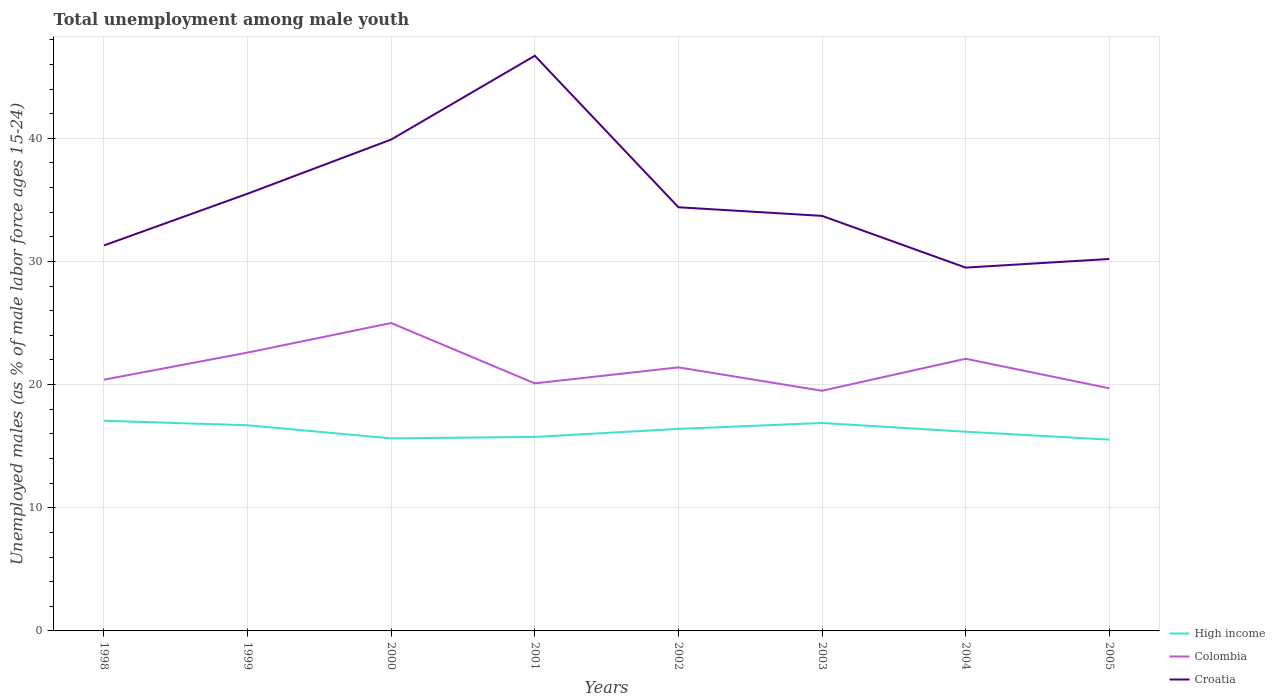How many different coloured lines are there?
Ensure brevity in your answer.  3. Does the line corresponding to Colombia intersect with the line corresponding to Croatia?
Keep it short and to the point. No. Is the number of lines equal to the number of legend labels?
Your answer should be very brief. Yes. Across all years, what is the maximum percentage of unemployed males in in Colombia?
Make the answer very short. 19.5. In which year was the percentage of unemployed males in in Croatia maximum?
Offer a very short reply. 2004. What is the total percentage of unemployed males in in Colombia in the graph?
Ensure brevity in your answer.  -1.3. What is the difference between the highest and the second highest percentage of unemployed males in in Croatia?
Your answer should be very brief. 17.2. How many lines are there?
Offer a terse response. 3. How many years are there in the graph?
Ensure brevity in your answer.  8. What is the title of the graph?
Your response must be concise. Total unemployment among male youth. Does "Timor-Leste" appear as one of the legend labels in the graph?
Provide a short and direct response. No. What is the label or title of the X-axis?
Your answer should be compact. Years. What is the label or title of the Y-axis?
Keep it short and to the point. Unemployed males (as % of male labor force ages 15-24). What is the Unemployed males (as % of male labor force ages 15-24) of High income in 1998?
Your answer should be very brief. 17.06. What is the Unemployed males (as % of male labor force ages 15-24) of Colombia in 1998?
Your response must be concise. 20.4. What is the Unemployed males (as % of male labor force ages 15-24) in Croatia in 1998?
Your answer should be very brief. 31.3. What is the Unemployed males (as % of male labor force ages 15-24) of High income in 1999?
Offer a very short reply. 16.7. What is the Unemployed males (as % of male labor force ages 15-24) of Colombia in 1999?
Give a very brief answer. 22.6. What is the Unemployed males (as % of male labor force ages 15-24) in Croatia in 1999?
Offer a very short reply. 35.5. What is the Unemployed males (as % of male labor force ages 15-24) of High income in 2000?
Your response must be concise. 15.63. What is the Unemployed males (as % of male labor force ages 15-24) of Croatia in 2000?
Make the answer very short. 39.9. What is the Unemployed males (as % of male labor force ages 15-24) of High income in 2001?
Ensure brevity in your answer.  15.75. What is the Unemployed males (as % of male labor force ages 15-24) in Colombia in 2001?
Your answer should be very brief. 20.1. What is the Unemployed males (as % of male labor force ages 15-24) in Croatia in 2001?
Provide a short and direct response. 46.7. What is the Unemployed males (as % of male labor force ages 15-24) in High income in 2002?
Keep it short and to the point. 16.4. What is the Unemployed males (as % of male labor force ages 15-24) of Colombia in 2002?
Your answer should be very brief. 21.4. What is the Unemployed males (as % of male labor force ages 15-24) of Croatia in 2002?
Provide a succinct answer. 34.4. What is the Unemployed males (as % of male labor force ages 15-24) of High income in 2003?
Keep it short and to the point. 16.88. What is the Unemployed males (as % of male labor force ages 15-24) of Croatia in 2003?
Provide a succinct answer. 33.7. What is the Unemployed males (as % of male labor force ages 15-24) of High income in 2004?
Offer a very short reply. 16.18. What is the Unemployed males (as % of male labor force ages 15-24) of Colombia in 2004?
Your answer should be compact. 22.1. What is the Unemployed males (as % of male labor force ages 15-24) in Croatia in 2004?
Keep it short and to the point. 29.5. What is the Unemployed males (as % of male labor force ages 15-24) of High income in 2005?
Give a very brief answer. 15.53. What is the Unemployed males (as % of male labor force ages 15-24) in Colombia in 2005?
Provide a succinct answer. 19.7. What is the Unemployed males (as % of male labor force ages 15-24) of Croatia in 2005?
Give a very brief answer. 30.2. Across all years, what is the maximum Unemployed males (as % of male labor force ages 15-24) of High income?
Ensure brevity in your answer.  17.06. Across all years, what is the maximum Unemployed males (as % of male labor force ages 15-24) in Croatia?
Make the answer very short. 46.7. Across all years, what is the minimum Unemployed males (as % of male labor force ages 15-24) of High income?
Your answer should be compact. 15.53. Across all years, what is the minimum Unemployed males (as % of male labor force ages 15-24) of Colombia?
Provide a succinct answer. 19.5. Across all years, what is the minimum Unemployed males (as % of male labor force ages 15-24) in Croatia?
Provide a short and direct response. 29.5. What is the total Unemployed males (as % of male labor force ages 15-24) of High income in the graph?
Make the answer very short. 130.14. What is the total Unemployed males (as % of male labor force ages 15-24) of Colombia in the graph?
Give a very brief answer. 170.8. What is the total Unemployed males (as % of male labor force ages 15-24) in Croatia in the graph?
Provide a short and direct response. 281.2. What is the difference between the Unemployed males (as % of male labor force ages 15-24) of High income in 1998 and that in 1999?
Offer a very short reply. 0.37. What is the difference between the Unemployed males (as % of male labor force ages 15-24) in Colombia in 1998 and that in 1999?
Offer a very short reply. -2.2. What is the difference between the Unemployed males (as % of male labor force ages 15-24) of Croatia in 1998 and that in 1999?
Ensure brevity in your answer.  -4.2. What is the difference between the Unemployed males (as % of male labor force ages 15-24) of High income in 1998 and that in 2000?
Offer a terse response. 1.43. What is the difference between the Unemployed males (as % of male labor force ages 15-24) of Colombia in 1998 and that in 2000?
Make the answer very short. -4.6. What is the difference between the Unemployed males (as % of male labor force ages 15-24) of Croatia in 1998 and that in 2000?
Provide a short and direct response. -8.6. What is the difference between the Unemployed males (as % of male labor force ages 15-24) of High income in 1998 and that in 2001?
Offer a terse response. 1.31. What is the difference between the Unemployed males (as % of male labor force ages 15-24) in Colombia in 1998 and that in 2001?
Make the answer very short. 0.3. What is the difference between the Unemployed males (as % of male labor force ages 15-24) in Croatia in 1998 and that in 2001?
Keep it short and to the point. -15.4. What is the difference between the Unemployed males (as % of male labor force ages 15-24) in High income in 1998 and that in 2002?
Offer a terse response. 0.66. What is the difference between the Unemployed males (as % of male labor force ages 15-24) of High income in 1998 and that in 2003?
Your answer should be very brief. 0.18. What is the difference between the Unemployed males (as % of male labor force ages 15-24) of Colombia in 1998 and that in 2003?
Your answer should be very brief. 0.9. What is the difference between the Unemployed males (as % of male labor force ages 15-24) in High income in 1998 and that in 2004?
Offer a terse response. 0.89. What is the difference between the Unemployed males (as % of male labor force ages 15-24) in Croatia in 1998 and that in 2004?
Provide a short and direct response. 1.8. What is the difference between the Unemployed males (as % of male labor force ages 15-24) in High income in 1998 and that in 2005?
Keep it short and to the point. 1.53. What is the difference between the Unemployed males (as % of male labor force ages 15-24) in Colombia in 1998 and that in 2005?
Provide a succinct answer. 0.7. What is the difference between the Unemployed males (as % of male labor force ages 15-24) in Croatia in 1998 and that in 2005?
Your answer should be very brief. 1.1. What is the difference between the Unemployed males (as % of male labor force ages 15-24) of High income in 1999 and that in 2000?
Provide a succinct answer. 1.06. What is the difference between the Unemployed males (as % of male labor force ages 15-24) in Croatia in 1999 and that in 2000?
Your answer should be compact. -4.4. What is the difference between the Unemployed males (as % of male labor force ages 15-24) in High income in 1999 and that in 2001?
Offer a terse response. 0.94. What is the difference between the Unemployed males (as % of male labor force ages 15-24) in High income in 1999 and that in 2002?
Keep it short and to the point. 0.29. What is the difference between the Unemployed males (as % of male labor force ages 15-24) in High income in 1999 and that in 2003?
Your answer should be compact. -0.19. What is the difference between the Unemployed males (as % of male labor force ages 15-24) in High income in 1999 and that in 2004?
Make the answer very short. 0.52. What is the difference between the Unemployed males (as % of male labor force ages 15-24) of Colombia in 1999 and that in 2004?
Give a very brief answer. 0.5. What is the difference between the Unemployed males (as % of male labor force ages 15-24) of High income in 1999 and that in 2005?
Make the answer very short. 1.17. What is the difference between the Unemployed males (as % of male labor force ages 15-24) in Colombia in 1999 and that in 2005?
Keep it short and to the point. 2.9. What is the difference between the Unemployed males (as % of male labor force ages 15-24) of Croatia in 1999 and that in 2005?
Your answer should be very brief. 5.3. What is the difference between the Unemployed males (as % of male labor force ages 15-24) in High income in 2000 and that in 2001?
Give a very brief answer. -0.12. What is the difference between the Unemployed males (as % of male labor force ages 15-24) in Croatia in 2000 and that in 2001?
Your response must be concise. -6.8. What is the difference between the Unemployed males (as % of male labor force ages 15-24) in High income in 2000 and that in 2002?
Make the answer very short. -0.77. What is the difference between the Unemployed males (as % of male labor force ages 15-24) of Colombia in 2000 and that in 2002?
Your answer should be compact. 3.6. What is the difference between the Unemployed males (as % of male labor force ages 15-24) of High income in 2000 and that in 2003?
Offer a very short reply. -1.25. What is the difference between the Unemployed males (as % of male labor force ages 15-24) in Croatia in 2000 and that in 2003?
Provide a short and direct response. 6.2. What is the difference between the Unemployed males (as % of male labor force ages 15-24) in High income in 2000 and that in 2004?
Provide a succinct answer. -0.54. What is the difference between the Unemployed males (as % of male labor force ages 15-24) of Colombia in 2000 and that in 2004?
Keep it short and to the point. 2.9. What is the difference between the Unemployed males (as % of male labor force ages 15-24) in Croatia in 2000 and that in 2004?
Offer a terse response. 10.4. What is the difference between the Unemployed males (as % of male labor force ages 15-24) in High income in 2000 and that in 2005?
Offer a terse response. 0.1. What is the difference between the Unemployed males (as % of male labor force ages 15-24) in Colombia in 2000 and that in 2005?
Keep it short and to the point. 5.3. What is the difference between the Unemployed males (as % of male labor force ages 15-24) of Croatia in 2000 and that in 2005?
Offer a very short reply. 9.7. What is the difference between the Unemployed males (as % of male labor force ages 15-24) of High income in 2001 and that in 2002?
Provide a succinct answer. -0.65. What is the difference between the Unemployed males (as % of male labor force ages 15-24) of High income in 2001 and that in 2003?
Keep it short and to the point. -1.13. What is the difference between the Unemployed males (as % of male labor force ages 15-24) in Croatia in 2001 and that in 2003?
Ensure brevity in your answer.  13. What is the difference between the Unemployed males (as % of male labor force ages 15-24) in High income in 2001 and that in 2004?
Give a very brief answer. -0.42. What is the difference between the Unemployed males (as % of male labor force ages 15-24) of Colombia in 2001 and that in 2004?
Keep it short and to the point. -2. What is the difference between the Unemployed males (as % of male labor force ages 15-24) of High income in 2001 and that in 2005?
Give a very brief answer. 0.22. What is the difference between the Unemployed males (as % of male labor force ages 15-24) in Croatia in 2001 and that in 2005?
Ensure brevity in your answer.  16.5. What is the difference between the Unemployed males (as % of male labor force ages 15-24) of High income in 2002 and that in 2003?
Give a very brief answer. -0.48. What is the difference between the Unemployed males (as % of male labor force ages 15-24) in Colombia in 2002 and that in 2003?
Your response must be concise. 1.9. What is the difference between the Unemployed males (as % of male labor force ages 15-24) of Croatia in 2002 and that in 2003?
Make the answer very short. 0.7. What is the difference between the Unemployed males (as % of male labor force ages 15-24) of High income in 2002 and that in 2004?
Your response must be concise. 0.23. What is the difference between the Unemployed males (as % of male labor force ages 15-24) in Croatia in 2002 and that in 2004?
Offer a terse response. 4.9. What is the difference between the Unemployed males (as % of male labor force ages 15-24) in High income in 2002 and that in 2005?
Your answer should be very brief. 0.87. What is the difference between the Unemployed males (as % of male labor force ages 15-24) in Colombia in 2002 and that in 2005?
Ensure brevity in your answer.  1.7. What is the difference between the Unemployed males (as % of male labor force ages 15-24) of High income in 2003 and that in 2004?
Offer a terse response. 0.71. What is the difference between the Unemployed males (as % of male labor force ages 15-24) in Colombia in 2003 and that in 2004?
Keep it short and to the point. -2.6. What is the difference between the Unemployed males (as % of male labor force ages 15-24) of High income in 2003 and that in 2005?
Your answer should be very brief. 1.35. What is the difference between the Unemployed males (as % of male labor force ages 15-24) of Colombia in 2003 and that in 2005?
Your response must be concise. -0.2. What is the difference between the Unemployed males (as % of male labor force ages 15-24) in Croatia in 2003 and that in 2005?
Offer a very short reply. 3.5. What is the difference between the Unemployed males (as % of male labor force ages 15-24) in High income in 2004 and that in 2005?
Your answer should be very brief. 0.64. What is the difference between the Unemployed males (as % of male labor force ages 15-24) of Colombia in 2004 and that in 2005?
Ensure brevity in your answer.  2.4. What is the difference between the Unemployed males (as % of male labor force ages 15-24) in Croatia in 2004 and that in 2005?
Ensure brevity in your answer.  -0.7. What is the difference between the Unemployed males (as % of male labor force ages 15-24) of High income in 1998 and the Unemployed males (as % of male labor force ages 15-24) of Colombia in 1999?
Make the answer very short. -5.54. What is the difference between the Unemployed males (as % of male labor force ages 15-24) of High income in 1998 and the Unemployed males (as % of male labor force ages 15-24) of Croatia in 1999?
Your answer should be compact. -18.43. What is the difference between the Unemployed males (as % of male labor force ages 15-24) of Colombia in 1998 and the Unemployed males (as % of male labor force ages 15-24) of Croatia in 1999?
Give a very brief answer. -15.1. What is the difference between the Unemployed males (as % of male labor force ages 15-24) in High income in 1998 and the Unemployed males (as % of male labor force ages 15-24) in Colombia in 2000?
Your answer should be compact. -7.93. What is the difference between the Unemployed males (as % of male labor force ages 15-24) of High income in 1998 and the Unemployed males (as % of male labor force ages 15-24) of Croatia in 2000?
Provide a succinct answer. -22.84. What is the difference between the Unemployed males (as % of male labor force ages 15-24) of Colombia in 1998 and the Unemployed males (as % of male labor force ages 15-24) of Croatia in 2000?
Your answer should be compact. -19.5. What is the difference between the Unemployed males (as % of male labor force ages 15-24) in High income in 1998 and the Unemployed males (as % of male labor force ages 15-24) in Colombia in 2001?
Provide a short and direct response. -3.04. What is the difference between the Unemployed males (as % of male labor force ages 15-24) of High income in 1998 and the Unemployed males (as % of male labor force ages 15-24) of Croatia in 2001?
Make the answer very short. -29.64. What is the difference between the Unemployed males (as % of male labor force ages 15-24) in Colombia in 1998 and the Unemployed males (as % of male labor force ages 15-24) in Croatia in 2001?
Make the answer very short. -26.3. What is the difference between the Unemployed males (as % of male labor force ages 15-24) of High income in 1998 and the Unemployed males (as % of male labor force ages 15-24) of Colombia in 2002?
Make the answer very short. -4.33. What is the difference between the Unemployed males (as % of male labor force ages 15-24) in High income in 1998 and the Unemployed males (as % of male labor force ages 15-24) in Croatia in 2002?
Offer a terse response. -17.34. What is the difference between the Unemployed males (as % of male labor force ages 15-24) of Colombia in 1998 and the Unemployed males (as % of male labor force ages 15-24) of Croatia in 2002?
Your answer should be very brief. -14. What is the difference between the Unemployed males (as % of male labor force ages 15-24) in High income in 1998 and the Unemployed males (as % of male labor force ages 15-24) in Colombia in 2003?
Your answer should be very brief. -2.44. What is the difference between the Unemployed males (as % of male labor force ages 15-24) in High income in 1998 and the Unemployed males (as % of male labor force ages 15-24) in Croatia in 2003?
Make the answer very short. -16.64. What is the difference between the Unemployed males (as % of male labor force ages 15-24) of Colombia in 1998 and the Unemployed males (as % of male labor force ages 15-24) of Croatia in 2003?
Offer a very short reply. -13.3. What is the difference between the Unemployed males (as % of male labor force ages 15-24) of High income in 1998 and the Unemployed males (as % of male labor force ages 15-24) of Colombia in 2004?
Offer a very short reply. -5.04. What is the difference between the Unemployed males (as % of male labor force ages 15-24) in High income in 1998 and the Unemployed males (as % of male labor force ages 15-24) in Croatia in 2004?
Give a very brief answer. -12.44. What is the difference between the Unemployed males (as % of male labor force ages 15-24) of High income in 1998 and the Unemployed males (as % of male labor force ages 15-24) of Colombia in 2005?
Offer a very short reply. -2.63. What is the difference between the Unemployed males (as % of male labor force ages 15-24) of High income in 1998 and the Unemployed males (as % of male labor force ages 15-24) of Croatia in 2005?
Keep it short and to the point. -13.13. What is the difference between the Unemployed males (as % of male labor force ages 15-24) in High income in 1999 and the Unemployed males (as % of male labor force ages 15-24) in Colombia in 2000?
Offer a very short reply. -8.3. What is the difference between the Unemployed males (as % of male labor force ages 15-24) of High income in 1999 and the Unemployed males (as % of male labor force ages 15-24) of Croatia in 2000?
Keep it short and to the point. -23.2. What is the difference between the Unemployed males (as % of male labor force ages 15-24) in Colombia in 1999 and the Unemployed males (as % of male labor force ages 15-24) in Croatia in 2000?
Provide a short and direct response. -17.3. What is the difference between the Unemployed males (as % of male labor force ages 15-24) in High income in 1999 and the Unemployed males (as % of male labor force ages 15-24) in Colombia in 2001?
Ensure brevity in your answer.  -3.4. What is the difference between the Unemployed males (as % of male labor force ages 15-24) in High income in 1999 and the Unemployed males (as % of male labor force ages 15-24) in Croatia in 2001?
Offer a terse response. -30. What is the difference between the Unemployed males (as % of male labor force ages 15-24) of Colombia in 1999 and the Unemployed males (as % of male labor force ages 15-24) of Croatia in 2001?
Offer a terse response. -24.1. What is the difference between the Unemployed males (as % of male labor force ages 15-24) of High income in 1999 and the Unemployed males (as % of male labor force ages 15-24) of Colombia in 2002?
Keep it short and to the point. -4.7. What is the difference between the Unemployed males (as % of male labor force ages 15-24) of High income in 1999 and the Unemployed males (as % of male labor force ages 15-24) of Croatia in 2002?
Your answer should be very brief. -17.7. What is the difference between the Unemployed males (as % of male labor force ages 15-24) of Colombia in 1999 and the Unemployed males (as % of male labor force ages 15-24) of Croatia in 2002?
Your answer should be very brief. -11.8. What is the difference between the Unemployed males (as % of male labor force ages 15-24) in High income in 1999 and the Unemployed males (as % of male labor force ages 15-24) in Colombia in 2003?
Offer a very short reply. -2.8. What is the difference between the Unemployed males (as % of male labor force ages 15-24) of High income in 1999 and the Unemployed males (as % of male labor force ages 15-24) of Croatia in 2003?
Your response must be concise. -17. What is the difference between the Unemployed males (as % of male labor force ages 15-24) of Colombia in 1999 and the Unemployed males (as % of male labor force ages 15-24) of Croatia in 2003?
Provide a short and direct response. -11.1. What is the difference between the Unemployed males (as % of male labor force ages 15-24) of High income in 1999 and the Unemployed males (as % of male labor force ages 15-24) of Colombia in 2004?
Your answer should be very brief. -5.4. What is the difference between the Unemployed males (as % of male labor force ages 15-24) in High income in 1999 and the Unemployed males (as % of male labor force ages 15-24) in Croatia in 2004?
Keep it short and to the point. -12.8. What is the difference between the Unemployed males (as % of male labor force ages 15-24) of Colombia in 1999 and the Unemployed males (as % of male labor force ages 15-24) of Croatia in 2004?
Your answer should be very brief. -6.9. What is the difference between the Unemployed males (as % of male labor force ages 15-24) of High income in 1999 and the Unemployed males (as % of male labor force ages 15-24) of Colombia in 2005?
Offer a very short reply. -3. What is the difference between the Unemployed males (as % of male labor force ages 15-24) of High income in 1999 and the Unemployed males (as % of male labor force ages 15-24) of Croatia in 2005?
Provide a succinct answer. -13.5. What is the difference between the Unemployed males (as % of male labor force ages 15-24) of High income in 2000 and the Unemployed males (as % of male labor force ages 15-24) of Colombia in 2001?
Give a very brief answer. -4.47. What is the difference between the Unemployed males (as % of male labor force ages 15-24) in High income in 2000 and the Unemployed males (as % of male labor force ages 15-24) in Croatia in 2001?
Ensure brevity in your answer.  -31.07. What is the difference between the Unemployed males (as % of male labor force ages 15-24) in Colombia in 2000 and the Unemployed males (as % of male labor force ages 15-24) in Croatia in 2001?
Your response must be concise. -21.7. What is the difference between the Unemployed males (as % of male labor force ages 15-24) of High income in 2000 and the Unemployed males (as % of male labor force ages 15-24) of Colombia in 2002?
Keep it short and to the point. -5.77. What is the difference between the Unemployed males (as % of male labor force ages 15-24) of High income in 2000 and the Unemployed males (as % of male labor force ages 15-24) of Croatia in 2002?
Your response must be concise. -18.77. What is the difference between the Unemployed males (as % of male labor force ages 15-24) of High income in 2000 and the Unemployed males (as % of male labor force ages 15-24) of Colombia in 2003?
Ensure brevity in your answer.  -3.87. What is the difference between the Unemployed males (as % of male labor force ages 15-24) of High income in 2000 and the Unemployed males (as % of male labor force ages 15-24) of Croatia in 2003?
Your answer should be very brief. -18.07. What is the difference between the Unemployed males (as % of male labor force ages 15-24) of Colombia in 2000 and the Unemployed males (as % of male labor force ages 15-24) of Croatia in 2003?
Keep it short and to the point. -8.7. What is the difference between the Unemployed males (as % of male labor force ages 15-24) in High income in 2000 and the Unemployed males (as % of male labor force ages 15-24) in Colombia in 2004?
Provide a short and direct response. -6.47. What is the difference between the Unemployed males (as % of male labor force ages 15-24) of High income in 2000 and the Unemployed males (as % of male labor force ages 15-24) of Croatia in 2004?
Give a very brief answer. -13.87. What is the difference between the Unemployed males (as % of male labor force ages 15-24) of Colombia in 2000 and the Unemployed males (as % of male labor force ages 15-24) of Croatia in 2004?
Provide a succinct answer. -4.5. What is the difference between the Unemployed males (as % of male labor force ages 15-24) of High income in 2000 and the Unemployed males (as % of male labor force ages 15-24) of Colombia in 2005?
Provide a succinct answer. -4.07. What is the difference between the Unemployed males (as % of male labor force ages 15-24) of High income in 2000 and the Unemployed males (as % of male labor force ages 15-24) of Croatia in 2005?
Provide a succinct answer. -14.57. What is the difference between the Unemployed males (as % of male labor force ages 15-24) of High income in 2001 and the Unemployed males (as % of male labor force ages 15-24) of Colombia in 2002?
Provide a succinct answer. -5.65. What is the difference between the Unemployed males (as % of male labor force ages 15-24) in High income in 2001 and the Unemployed males (as % of male labor force ages 15-24) in Croatia in 2002?
Offer a terse response. -18.65. What is the difference between the Unemployed males (as % of male labor force ages 15-24) in Colombia in 2001 and the Unemployed males (as % of male labor force ages 15-24) in Croatia in 2002?
Ensure brevity in your answer.  -14.3. What is the difference between the Unemployed males (as % of male labor force ages 15-24) in High income in 2001 and the Unemployed males (as % of male labor force ages 15-24) in Colombia in 2003?
Make the answer very short. -3.75. What is the difference between the Unemployed males (as % of male labor force ages 15-24) of High income in 2001 and the Unemployed males (as % of male labor force ages 15-24) of Croatia in 2003?
Your answer should be compact. -17.95. What is the difference between the Unemployed males (as % of male labor force ages 15-24) in High income in 2001 and the Unemployed males (as % of male labor force ages 15-24) in Colombia in 2004?
Your response must be concise. -6.35. What is the difference between the Unemployed males (as % of male labor force ages 15-24) of High income in 2001 and the Unemployed males (as % of male labor force ages 15-24) of Croatia in 2004?
Your answer should be very brief. -13.75. What is the difference between the Unemployed males (as % of male labor force ages 15-24) in Colombia in 2001 and the Unemployed males (as % of male labor force ages 15-24) in Croatia in 2004?
Provide a short and direct response. -9.4. What is the difference between the Unemployed males (as % of male labor force ages 15-24) in High income in 2001 and the Unemployed males (as % of male labor force ages 15-24) in Colombia in 2005?
Offer a terse response. -3.95. What is the difference between the Unemployed males (as % of male labor force ages 15-24) of High income in 2001 and the Unemployed males (as % of male labor force ages 15-24) of Croatia in 2005?
Your answer should be compact. -14.45. What is the difference between the Unemployed males (as % of male labor force ages 15-24) of High income in 2002 and the Unemployed males (as % of male labor force ages 15-24) of Colombia in 2003?
Keep it short and to the point. -3.1. What is the difference between the Unemployed males (as % of male labor force ages 15-24) in High income in 2002 and the Unemployed males (as % of male labor force ages 15-24) in Croatia in 2003?
Offer a very short reply. -17.3. What is the difference between the Unemployed males (as % of male labor force ages 15-24) in High income in 2002 and the Unemployed males (as % of male labor force ages 15-24) in Colombia in 2004?
Offer a very short reply. -5.7. What is the difference between the Unemployed males (as % of male labor force ages 15-24) of High income in 2002 and the Unemployed males (as % of male labor force ages 15-24) of Croatia in 2004?
Offer a terse response. -13.1. What is the difference between the Unemployed males (as % of male labor force ages 15-24) in High income in 2002 and the Unemployed males (as % of male labor force ages 15-24) in Colombia in 2005?
Ensure brevity in your answer.  -3.3. What is the difference between the Unemployed males (as % of male labor force ages 15-24) of High income in 2002 and the Unemployed males (as % of male labor force ages 15-24) of Croatia in 2005?
Your answer should be very brief. -13.8. What is the difference between the Unemployed males (as % of male labor force ages 15-24) in High income in 2003 and the Unemployed males (as % of male labor force ages 15-24) in Colombia in 2004?
Keep it short and to the point. -5.22. What is the difference between the Unemployed males (as % of male labor force ages 15-24) in High income in 2003 and the Unemployed males (as % of male labor force ages 15-24) in Croatia in 2004?
Make the answer very short. -12.62. What is the difference between the Unemployed males (as % of male labor force ages 15-24) in High income in 2003 and the Unemployed males (as % of male labor force ages 15-24) in Colombia in 2005?
Make the answer very short. -2.82. What is the difference between the Unemployed males (as % of male labor force ages 15-24) of High income in 2003 and the Unemployed males (as % of male labor force ages 15-24) of Croatia in 2005?
Offer a terse response. -13.32. What is the difference between the Unemployed males (as % of male labor force ages 15-24) of High income in 2004 and the Unemployed males (as % of male labor force ages 15-24) of Colombia in 2005?
Your response must be concise. -3.52. What is the difference between the Unemployed males (as % of male labor force ages 15-24) in High income in 2004 and the Unemployed males (as % of male labor force ages 15-24) in Croatia in 2005?
Offer a very short reply. -14.02. What is the difference between the Unemployed males (as % of male labor force ages 15-24) of Colombia in 2004 and the Unemployed males (as % of male labor force ages 15-24) of Croatia in 2005?
Your answer should be very brief. -8.1. What is the average Unemployed males (as % of male labor force ages 15-24) of High income per year?
Ensure brevity in your answer.  16.27. What is the average Unemployed males (as % of male labor force ages 15-24) in Colombia per year?
Provide a succinct answer. 21.35. What is the average Unemployed males (as % of male labor force ages 15-24) of Croatia per year?
Your answer should be very brief. 35.15. In the year 1998, what is the difference between the Unemployed males (as % of male labor force ages 15-24) in High income and Unemployed males (as % of male labor force ages 15-24) in Colombia?
Your answer should be compact. -3.33. In the year 1998, what is the difference between the Unemployed males (as % of male labor force ages 15-24) in High income and Unemployed males (as % of male labor force ages 15-24) in Croatia?
Offer a terse response. -14.23. In the year 1998, what is the difference between the Unemployed males (as % of male labor force ages 15-24) in Colombia and Unemployed males (as % of male labor force ages 15-24) in Croatia?
Your response must be concise. -10.9. In the year 1999, what is the difference between the Unemployed males (as % of male labor force ages 15-24) of High income and Unemployed males (as % of male labor force ages 15-24) of Colombia?
Make the answer very short. -5.9. In the year 1999, what is the difference between the Unemployed males (as % of male labor force ages 15-24) of High income and Unemployed males (as % of male labor force ages 15-24) of Croatia?
Your answer should be compact. -18.8. In the year 1999, what is the difference between the Unemployed males (as % of male labor force ages 15-24) of Colombia and Unemployed males (as % of male labor force ages 15-24) of Croatia?
Make the answer very short. -12.9. In the year 2000, what is the difference between the Unemployed males (as % of male labor force ages 15-24) of High income and Unemployed males (as % of male labor force ages 15-24) of Colombia?
Your response must be concise. -9.37. In the year 2000, what is the difference between the Unemployed males (as % of male labor force ages 15-24) in High income and Unemployed males (as % of male labor force ages 15-24) in Croatia?
Keep it short and to the point. -24.27. In the year 2000, what is the difference between the Unemployed males (as % of male labor force ages 15-24) in Colombia and Unemployed males (as % of male labor force ages 15-24) in Croatia?
Make the answer very short. -14.9. In the year 2001, what is the difference between the Unemployed males (as % of male labor force ages 15-24) of High income and Unemployed males (as % of male labor force ages 15-24) of Colombia?
Keep it short and to the point. -4.35. In the year 2001, what is the difference between the Unemployed males (as % of male labor force ages 15-24) in High income and Unemployed males (as % of male labor force ages 15-24) in Croatia?
Offer a terse response. -30.95. In the year 2001, what is the difference between the Unemployed males (as % of male labor force ages 15-24) in Colombia and Unemployed males (as % of male labor force ages 15-24) in Croatia?
Offer a very short reply. -26.6. In the year 2002, what is the difference between the Unemployed males (as % of male labor force ages 15-24) in High income and Unemployed males (as % of male labor force ages 15-24) in Colombia?
Make the answer very short. -5. In the year 2002, what is the difference between the Unemployed males (as % of male labor force ages 15-24) in High income and Unemployed males (as % of male labor force ages 15-24) in Croatia?
Offer a very short reply. -18. In the year 2003, what is the difference between the Unemployed males (as % of male labor force ages 15-24) of High income and Unemployed males (as % of male labor force ages 15-24) of Colombia?
Keep it short and to the point. -2.62. In the year 2003, what is the difference between the Unemployed males (as % of male labor force ages 15-24) in High income and Unemployed males (as % of male labor force ages 15-24) in Croatia?
Your answer should be very brief. -16.82. In the year 2004, what is the difference between the Unemployed males (as % of male labor force ages 15-24) of High income and Unemployed males (as % of male labor force ages 15-24) of Colombia?
Make the answer very short. -5.92. In the year 2004, what is the difference between the Unemployed males (as % of male labor force ages 15-24) of High income and Unemployed males (as % of male labor force ages 15-24) of Croatia?
Give a very brief answer. -13.32. In the year 2005, what is the difference between the Unemployed males (as % of male labor force ages 15-24) in High income and Unemployed males (as % of male labor force ages 15-24) in Colombia?
Your answer should be very brief. -4.17. In the year 2005, what is the difference between the Unemployed males (as % of male labor force ages 15-24) in High income and Unemployed males (as % of male labor force ages 15-24) in Croatia?
Your answer should be compact. -14.67. What is the ratio of the Unemployed males (as % of male labor force ages 15-24) in High income in 1998 to that in 1999?
Your answer should be very brief. 1.02. What is the ratio of the Unemployed males (as % of male labor force ages 15-24) in Colombia in 1998 to that in 1999?
Your answer should be very brief. 0.9. What is the ratio of the Unemployed males (as % of male labor force ages 15-24) of Croatia in 1998 to that in 1999?
Your response must be concise. 0.88. What is the ratio of the Unemployed males (as % of male labor force ages 15-24) of High income in 1998 to that in 2000?
Offer a terse response. 1.09. What is the ratio of the Unemployed males (as % of male labor force ages 15-24) of Colombia in 1998 to that in 2000?
Provide a succinct answer. 0.82. What is the ratio of the Unemployed males (as % of male labor force ages 15-24) in Croatia in 1998 to that in 2000?
Make the answer very short. 0.78. What is the ratio of the Unemployed males (as % of male labor force ages 15-24) in High income in 1998 to that in 2001?
Make the answer very short. 1.08. What is the ratio of the Unemployed males (as % of male labor force ages 15-24) of Colombia in 1998 to that in 2001?
Ensure brevity in your answer.  1.01. What is the ratio of the Unemployed males (as % of male labor force ages 15-24) of Croatia in 1998 to that in 2001?
Provide a short and direct response. 0.67. What is the ratio of the Unemployed males (as % of male labor force ages 15-24) of High income in 1998 to that in 2002?
Provide a succinct answer. 1.04. What is the ratio of the Unemployed males (as % of male labor force ages 15-24) in Colombia in 1998 to that in 2002?
Your answer should be very brief. 0.95. What is the ratio of the Unemployed males (as % of male labor force ages 15-24) in Croatia in 1998 to that in 2002?
Your response must be concise. 0.91. What is the ratio of the Unemployed males (as % of male labor force ages 15-24) of High income in 1998 to that in 2003?
Provide a succinct answer. 1.01. What is the ratio of the Unemployed males (as % of male labor force ages 15-24) in Colombia in 1998 to that in 2003?
Offer a very short reply. 1.05. What is the ratio of the Unemployed males (as % of male labor force ages 15-24) of Croatia in 1998 to that in 2003?
Your answer should be compact. 0.93. What is the ratio of the Unemployed males (as % of male labor force ages 15-24) of High income in 1998 to that in 2004?
Give a very brief answer. 1.05. What is the ratio of the Unemployed males (as % of male labor force ages 15-24) of Colombia in 1998 to that in 2004?
Your response must be concise. 0.92. What is the ratio of the Unemployed males (as % of male labor force ages 15-24) in Croatia in 1998 to that in 2004?
Your response must be concise. 1.06. What is the ratio of the Unemployed males (as % of male labor force ages 15-24) of High income in 1998 to that in 2005?
Keep it short and to the point. 1.1. What is the ratio of the Unemployed males (as % of male labor force ages 15-24) of Colombia in 1998 to that in 2005?
Your response must be concise. 1.04. What is the ratio of the Unemployed males (as % of male labor force ages 15-24) of Croatia in 1998 to that in 2005?
Ensure brevity in your answer.  1.04. What is the ratio of the Unemployed males (as % of male labor force ages 15-24) in High income in 1999 to that in 2000?
Your response must be concise. 1.07. What is the ratio of the Unemployed males (as % of male labor force ages 15-24) in Colombia in 1999 to that in 2000?
Give a very brief answer. 0.9. What is the ratio of the Unemployed males (as % of male labor force ages 15-24) in Croatia in 1999 to that in 2000?
Your answer should be very brief. 0.89. What is the ratio of the Unemployed males (as % of male labor force ages 15-24) of High income in 1999 to that in 2001?
Provide a succinct answer. 1.06. What is the ratio of the Unemployed males (as % of male labor force ages 15-24) in Colombia in 1999 to that in 2001?
Provide a succinct answer. 1.12. What is the ratio of the Unemployed males (as % of male labor force ages 15-24) in Croatia in 1999 to that in 2001?
Keep it short and to the point. 0.76. What is the ratio of the Unemployed males (as % of male labor force ages 15-24) in Colombia in 1999 to that in 2002?
Make the answer very short. 1.06. What is the ratio of the Unemployed males (as % of male labor force ages 15-24) of Croatia in 1999 to that in 2002?
Provide a short and direct response. 1.03. What is the ratio of the Unemployed males (as % of male labor force ages 15-24) in High income in 1999 to that in 2003?
Offer a terse response. 0.99. What is the ratio of the Unemployed males (as % of male labor force ages 15-24) in Colombia in 1999 to that in 2003?
Ensure brevity in your answer.  1.16. What is the ratio of the Unemployed males (as % of male labor force ages 15-24) of Croatia in 1999 to that in 2003?
Ensure brevity in your answer.  1.05. What is the ratio of the Unemployed males (as % of male labor force ages 15-24) of High income in 1999 to that in 2004?
Offer a terse response. 1.03. What is the ratio of the Unemployed males (as % of male labor force ages 15-24) of Colombia in 1999 to that in 2004?
Provide a short and direct response. 1.02. What is the ratio of the Unemployed males (as % of male labor force ages 15-24) in Croatia in 1999 to that in 2004?
Make the answer very short. 1.2. What is the ratio of the Unemployed males (as % of male labor force ages 15-24) of High income in 1999 to that in 2005?
Ensure brevity in your answer.  1.08. What is the ratio of the Unemployed males (as % of male labor force ages 15-24) of Colombia in 1999 to that in 2005?
Offer a very short reply. 1.15. What is the ratio of the Unemployed males (as % of male labor force ages 15-24) in Croatia in 1999 to that in 2005?
Your response must be concise. 1.18. What is the ratio of the Unemployed males (as % of male labor force ages 15-24) in Colombia in 2000 to that in 2001?
Provide a succinct answer. 1.24. What is the ratio of the Unemployed males (as % of male labor force ages 15-24) of Croatia in 2000 to that in 2001?
Ensure brevity in your answer.  0.85. What is the ratio of the Unemployed males (as % of male labor force ages 15-24) in High income in 2000 to that in 2002?
Offer a terse response. 0.95. What is the ratio of the Unemployed males (as % of male labor force ages 15-24) in Colombia in 2000 to that in 2002?
Your response must be concise. 1.17. What is the ratio of the Unemployed males (as % of male labor force ages 15-24) of Croatia in 2000 to that in 2002?
Ensure brevity in your answer.  1.16. What is the ratio of the Unemployed males (as % of male labor force ages 15-24) in High income in 2000 to that in 2003?
Your answer should be compact. 0.93. What is the ratio of the Unemployed males (as % of male labor force ages 15-24) of Colombia in 2000 to that in 2003?
Offer a very short reply. 1.28. What is the ratio of the Unemployed males (as % of male labor force ages 15-24) of Croatia in 2000 to that in 2003?
Your answer should be very brief. 1.18. What is the ratio of the Unemployed males (as % of male labor force ages 15-24) of High income in 2000 to that in 2004?
Give a very brief answer. 0.97. What is the ratio of the Unemployed males (as % of male labor force ages 15-24) in Colombia in 2000 to that in 2004?
Your answer should be very brief. 1.13. What is the ratio of the Unemployed males (as % of male labor force ages 15-24) in Croatia in 2000 to that in 2004?
Your response must be concise. 1.35. What is the ratio of the Unemployed males (as % of male labor force ages 15-24) of High income in 2000 to that in 2005?
Keep it short and to the point. 1.01. What is the ratio of the Unemployed males (as % of male labor force ages 15-24) in Colombia in 2000 to that in 2005?
Provide a short and direct response. 1.27. What is the ratio of the Unemployed males (as % of male labor force ages 15-24) of Croatia in 2000 to that in 2005?
Make the answer very short. 1.32. What is the ratio of the Unemployed males (as % of male labor force ages 15-24) in High income in 2001 to that in 2002?
Make the answer very short. 0.96. What is the ratio of the Unemployed males (as % of male labor force ages 15-24) in Colombia in 2001 to that in 2002?
Provide a succinct answer. 0.94. What is the ratio of the Unemployed males (as % of male labor force ages 15-24) of Croatia in 2001 to that in 2002?
Your answer should be compact. 1.36. What is the ratio of the Unemployed males (as % of male labor force ages 15-24) of High income in 2001 to that in 2003?
Give a very brief answer. 0.93. What is the ratio of the Unemployed males (as % of male labor force ages 15-24) in Colombia in 2001 to that in 2003?
Your answer should be very brief. 1.03. What is the ratio of the Unemployed males (as % of male labor force ages 15-24) in Croatia in 2001 to that in 2003?
Offer a terse response. 1.39. What is the ratio of the Unemployed males (as % of male labor force ages 15-24) of High income in 2001 to that in 2004?
Provide a succinct answer. 0.97. What is the ratio of the Unemployed males (as % of male labor force ages 15-24) of Colombia in 2001 to that in 2004?
Provide a succinct answer. 0.91. What is the ratio of the Unemployed males (as % of male labor force ages 15-24) in Croatia in 2001 to that in 2004?
Ensure brevity in your answer.  1.58. What is the ratio of the Unemployed males (as % of male labor force ages 15-24) of High income in 2001 to that in 2005?
Provide a short and direct response. 1.01. What is the ratio of the Unemployed males (as % of male labor force ages 15-24) in Colombia in 2001 to that in 2005?
Keep it short and to the point. 1.02. What is the ratio of the Unemployed males (as % of male labor force ages 15-24) of Croatia in 2001 to that in 2005?
Give a very brief answer. 1.55. What is the ratio of the Unemployed males (as % of male labor force ages 15-24) in High income in 2002 to that in 2003?
Offer a very short reply. 0.97. What is the ratio of the Unemployed males (as % of male labor force ages 15-24) in Colombia in 2002 to that in 2003?
Offer a terse response. 1.1. What is the ratio of the Unemployed males (as % of male labor force ages 15-24) in Croatia in 2002 to that in 2003?
Your answer should be very brief. 1.02. What is the ratio of the Unemployed males (as % of male labor force ages 15-24) in High income in 2002 to that in 2004?
Provide a succinct answer. 1.01. What is the ratio of the Unemployed males (as % of male labor force ages 15-24) of Colombia in 2002 to that in 2004?
Your answer should be compact. 0.97. What is the ratio of the Unemployed males (as % of male labor force ages 15-24) in Croatia in 2002 to that in 2004?
Offer a very short reply. 1.17. What is the ratio of the Unemployed males (as % of male labor force ages 15-24) of High income in 2002 to that in 2005?
Your answer should be compact. 1.06. What is the ratio of the Unemployed males (as % of male labor force ages 15-24) in Colombia in 2002 to that in 2005?
Offer a terse response. 1.09. What is the ratio of the Unemployed males (as % of male labor force ages 15-24) of Croatia in 2002 to that in 2005?
Offer a very short reply. 1.14. What is the ratio of the Unemployed males (as % of male labor force ages 15-24) of High income in 2003 to that in 2004?
Provide a short and direct response. 1.04. What is the ratio of the Unemployed males (as % of male labor force ages 15-24) of Colombia in 2003 to that in 2004?
Keep it short and to the point. 0.88. What is the ratio of the Unemployed males (as % of male labor force ages 15-24) in Croatia in 2003 to that in 2004?
Provide a short and direct response. 1.14. What is the ratio of the Unemployed males (as % of male labor force ages 15-24) of High income in 2003 to that in 2005?
Make the answer very short. 1.09. What is the ratio of the Unemployed males (as % of male labor force ages 15-24) of Colombia in 2003 to that in 2005?
Your answer should be compact. 0.99. What is the ratio of the Unemployed males (as % of male labor force ages 15-24) in Croatia in 2003 to that in 2005?
Keep it short and to the point. 1.12. What is the ratio of the Unemployed males (as % of male labor force ages 15-24) in High income in 2004 to that in 2005?
Give a very brief answer. 1.04. What is the ratio of the Unemployed males (as % of male labor force ages 15-24) in Colombia in 2004 to that in 2005?
Your answer should be compact. 1.12. What is the ratio of the Unemployed males (as % of male labor force ages 15-24) of Croatia in 2004 to that in 2005?
Your response must be concise. 0.98. What is the difference between the highest and the second highest Unemployed males (as % of male labor force ages 15-24) in High income?
Offer a terse response. 0.18. What is the difference between the highest and the lowest Unemployed males (as % of male labor force ages 15-24) of High income?
Your answer should be very brief. 1.53. What is the difference between the highest and the lowest Unemployed males (as % of male labor force ages 15-24) of Colombia?
Your answer should be compact. 5.5. What is the difference between the highest and the lowest Unemployed males (as % of male labor force ages 15-24) of Croatia?
Provide a succinct answer. 17.2. 